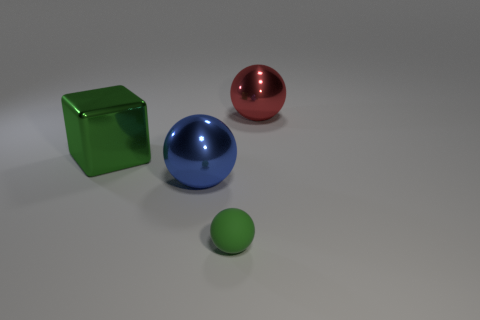What number of other things are made of the same material as the green ball?
Your answer should be compact. 0. Are there any other things that are the same size as the blue ball?
Offer a very short reply. Yes. There is a big object that is behind the large cube; does it have the same shape as the green rubber object?
Provide a succinct answer. Yes. The matte ball has what color?
Make the answer very short. Green. What color is the other large metal thing that is the same shape as the large blue object?
Ensure brevity in your answer.  Red. What number of green things have the same shape as the large blue object?
Your answer should be very brief. 1. How many things are either big green things or shiny things on the right side of the large green metal object?
Provide a succinct answer. 3. Do the shiny block and the sphere in front of the blue ball have the same color?
Your answer should be very brief. Yes. What is the size of the thing that is both left of the small ball and in front of the big green metallic thing?
Make the answer very short. Large. Are there any big spheres left of the red object?
Offer a very short reply. Yes. 